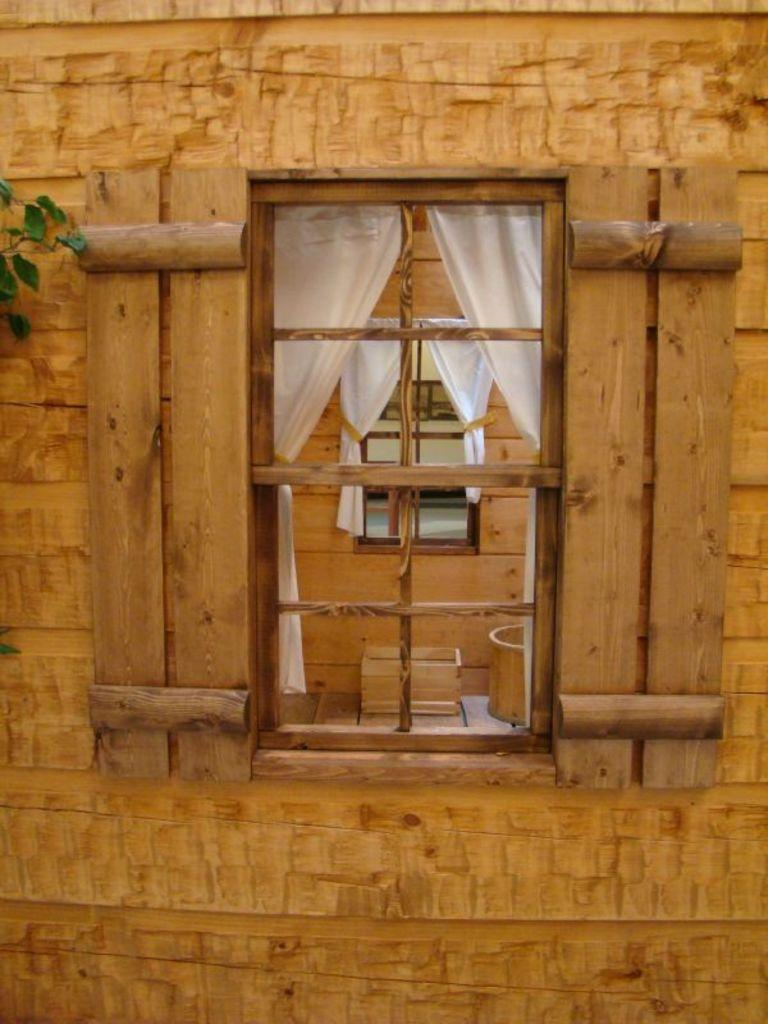What is the main feature of the wall in the image? There is a wall with a window in the image. What type of frame surrounds the window? The window has a wooden frame. What type of window treatment is present in the image? There are curtains associated with the window. What can be seen through the first window? Another wall with a window is visible through the first window. Are there curtains present on the second window? Yes, the second window also has curtains. What achievement is the wall celebrating in the image? The wall is not celebrating any achievement; it is simply a wall with a window and curtains. 